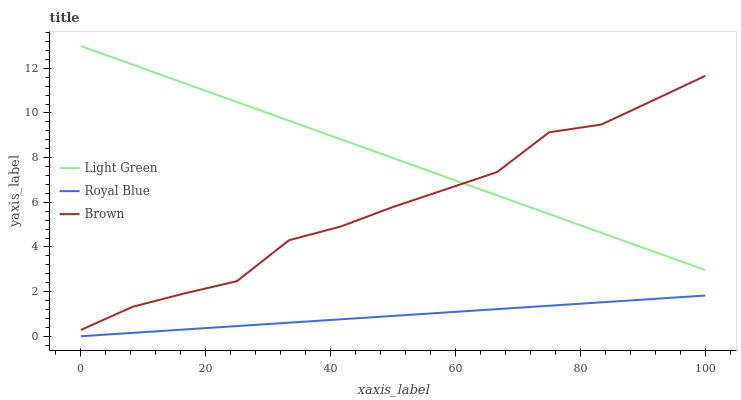Does Royal Blue have the minimum area under the curve?
Answer yes or no. Yes. Does Light Green have the maximum area under the curve?
Answer yes or no. Yes. Does Brown have the minimum area under the curve?
Answer yes or no. No. Does Brown have the maximum area under the curve?
Answer yes or no. No. Is Royal Blue the smoothest?
Answer yes or no. Yes. Is Brown the roughest?
Answer yes or no. Yes. Is Light Green the smoothest?
Answer yes or no. No. Is Light Green the roughest?
Answer yes or no. No. Does Brown have the lowest value?
Answer yes or no. No. Does Light Green have the highest value?
Answer yes or no. Yes. Does Brown have the highest value?
Answer yes or no. No. Is Royal Blue less than Brown?
Answer yes or no. Yes. Is Brown greater than Royal Blue?
Answer yes or no. Yes. Does Brown intersect Light Green?
Answer yes or no. Yes. Is Brown less than Light Green?
Answer yes or no. No. Is Brown greater than Light Green?
Answer yes or no. No. Does Royal Blue intersect Brown?
Answer yes or no. No. 